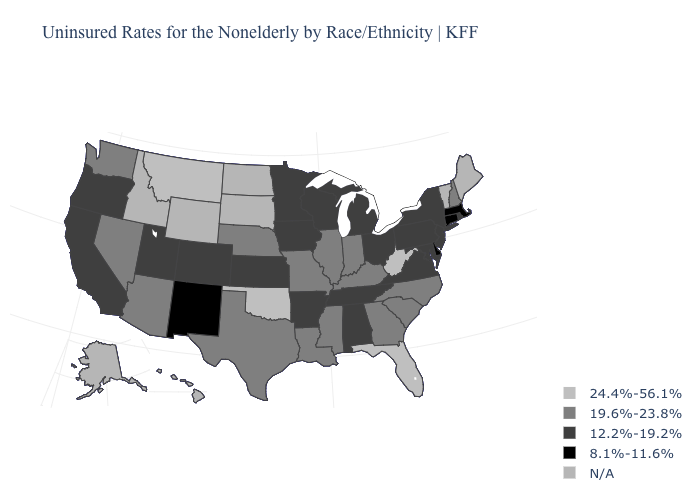What is the value of Maine?
Be succinct. N/A. What is the value of Idaho?
Quick response, please. N/A. Name the states that have a value in the range 19.6%-23.8%?
Short answer required. Arizona, Georgia, Illinois, Indiana, Kentucky, Louisiana, Mississippi, Missouri, Nebraska, Nevada, New Hampshire, North Carolina, South Carolina, Texas, Washington. What is the highest value in the MidWest ?
Be succinct. 19.6%-23.8%. Which states have the highest value in the USA?
Be succinct. Florida, Montana, Oklahoma, West Virginia. Which states have the highest value in the USA?
Give a very brief answer. Florida, Montana, Oklahoma, West Virginia. Among the states that border Arkansas , which have the highest value?
Give a very brief answer. Oklahoma. How many symbols are there in the legend?
Concise answer only. 5. Which states have the lowest value in the MidWest?
Be succinct. Iowa, Kansas, Michigan, Minnesota, Ohio, Wisconsin. What is the highest value in states that border Delaware?
Concise answer only. 12.2%-19.2%. How many symbols are there in the legend?
Short answer required. 5. Which states have the lowest value in the USA?
Concise answer only. Connecticut, Delaware, Massachusetts, New Mexico. 